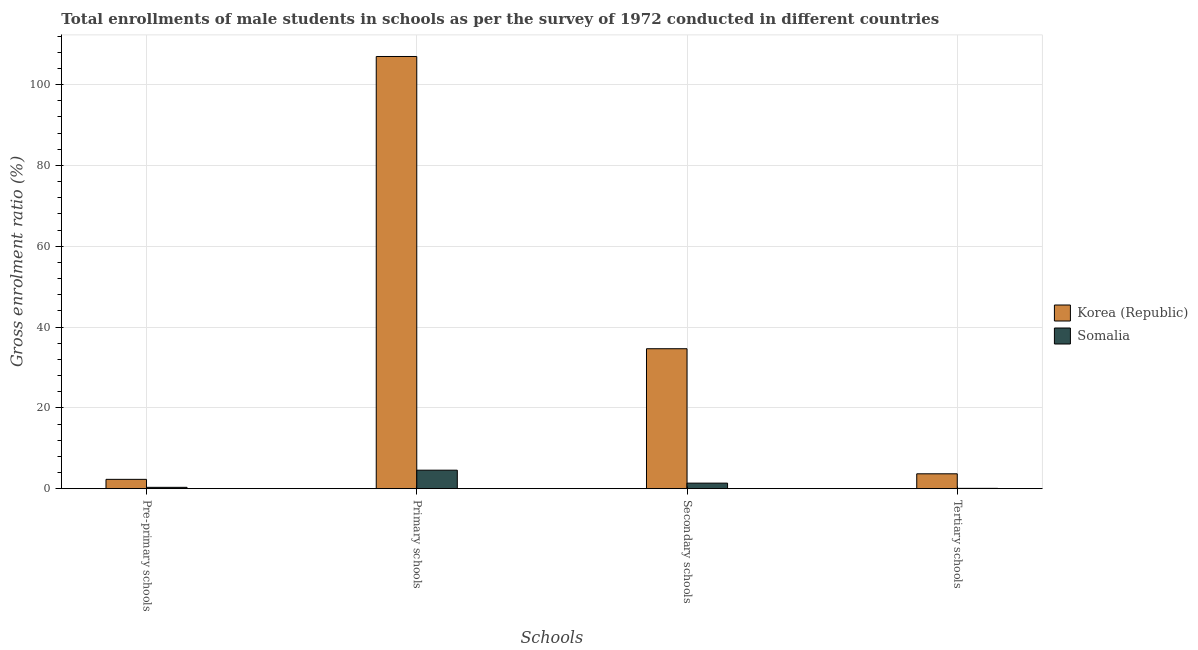How many groups of bars are there?
Your answer should be very brief. 4. Are the number of bars per tick equal to the number of legend labels?
Keep it short and to the point. Yes. Are the number of bars on each tick of the X-axis equal?
Keep it short and to the point. Yes. How many bars are there on the 3rd tick from the left?
Provide a succinct answer. 2. What is the label of the 3rd group of bars from the left?
Your answer should be very brief. Secondary schools. What is the gross enrolment ratio(male) in secondary schools in Korea (Republic)?
Your answer should be compact. 34.63. Across all countries, what is the maximum gross enrolment ratio(male) in tertiary schools?
Offer a very short reply. 3.68. Across all countries, what is the minimum gross enrolment ratio(male) in secondary schools?
Give a very brief answer. 1.37. In which country was the gross enrolment ratio(male) in pre-primary schools maximum?
Provide a short and direct response. Korea (Republic). In which country was the gross enrolment ratio(male) in primary schools minimum?
Your answer should be compact. Somalia. What is the total gross enrolment ratio(male) in secondary schools in the graph?
Offer a very short reply. 36. What is the difference between the gross enrolment ratio(male) in pre-primary schools in Korea (Republic) and that in Somalia?
Give a very brief answer. 1.97. What is the difference between the gross enrolment ratio(male) in tertiary schools in Korea (Republic) and the gross enrolment ratio(male) in pre-primary schools in Somalia?
Provide a succinct answer. 3.35. What is the average gross enrolment ratio(male) in tertiary schools per country?
Your response must be concise. 1.88. What is the difference between the gross enrolment ratio(male) in primary schools and gross enrolment ratio(male) in secondary schools in Somalia?
Make the answer very short. 3.2. What is the ratio of the gross enrolment ratio(male) in pre-primary schools in Korea (Republic) to that in Somalia?
Your response must be concise. 6.93. What is the difference between the highest and the second highest gross enrolment ratio(male) in primary schools?
Provide a short and direct response. 102.37. What is the difference between the highest and the lowest gross enrolment ratio(male) in primary schools?
Offer a terse response. 102.37. In how many countries, is the gross enrolment ratio(male) in secondary schools greater than the average gross enrolment ratio(male) in secondary schools taken over all countries?
Make the answer very short. 1. Is it the case that in every country, the sum of the gross enrolment ratio(male) in pre-primary schools and gross enrolment ratio(male) in tertiary schools is greater than the sum of gross enrolment ratio(male) in secondary schools and gross enrolment ratio(male) in primary schools?
Your answer should be compact. No. What does the 2nd bar from the left in Primary schools represents?
Your answer should be very brief. Somalia. How many bars are there?
Offer a very short reply. 8. How many countries are there in the graph?
Make the answer very short. 2. Are the values on the major ticks of Y-axis written in scientific E-notation?
Provide a short and direct response. No. How many legend labels are there?
Your answer should be very brief. 2. How are the legend labels stacked?
Ensure brevity in your answer.  Vertical. What is the title of the graph?
Provide a short and direct response. Total enrollments of male students in schools as per the survey of 1972 conducted in different countries. What is the label or title of the X-axis?
Provide a short and direct response. Schools. What is the Gross enrolment ratio (%) of Korea (Republic) in Pre-primary schools?
Provide a succinct answer. 2.31. What is the Gross enrolment ratio (%) in Somalia in Pre-primary schools?
Make the answer very short. 0.33. What is the Gross enrolment ratio (%) of Korea (Republic) in Primary schools?
Provide a succinct answer. 106.94. What is the Gross enrolment ratio (%) of Somalia in Primary schools?
Make the answer very short. 4.58. What is the Gross enrolment ratio (%) of Korea (Republic) in Secondary schools?
Offer a very short reply. 34.63. What is the Gross enrolment ratio (%) of Somalia in Secondary schools?
Give a very brief answer. 1.37. What is the Gross enrolment ratio (%) in Korea (Republic) in Tertiary schools?
Your answer should be compact. 3.68. What is the Gross enrolment ratio (%) of Somalia in Tertiary schools?
Your answer should be very brief. 0.08. Across all Schools, what is the maximum Gross enrolment ratio (%) of Korea (Republic)?
Your answer should be compact. 106.94. Across all Schools, what is the maximum Gross enrolment ratio (%) in Somalia?
Offer a very short reply. 4.58. Across all Schools, what is the minimum Gross enrolment ratio (%) in Korea (Republic)?
Make the answer very short. 2.31. Across all Schools, what is the minimum Gross enrolment ratio (%) in Somalia?
Make the answer very short. 0.08. What is the total Gross enrolment ratio (%) in Korea (Republic) in the graph?
Keep it short and to the point. 147.56. What is the total Gross enrolment ratio (%) of Somalia in the graph?
Give a very brief answer. 6.36. What is the difference between the Gross enrolment ratio (%) in Korea (Republic) in Pre-primary schools and that in Primary schools?
Make the answer very short. -104.64. What is the difference between the Gross enrolment ratio (%) of Somalia in Pre-primary schools and that in Primary schools?
Provide a short and direct response. -4.24. What is the difference between the Gross enrolment ratio (%) in Korea (Republic) in Pre-primary schools and that in Secondary schools?
Keep it short and to the point. -32.32. What is the difference between the Gross enrolment ratio (%) of Somalia in Pre-primary schools and that in Secondary schools?
Provide a short and direct response. -1.04. What is the difference between the Gross enrolment ratio (%) of Korea (Republic) in Pre-primary schools and that in Tertiary schools?
Keep it short and to the point. -1.37. What is the difference between the Gross enrolment ratio (%) in Somalia in Pre-primary schools and that in Tertiary schools?
Your answer should be compact. 0.25. What is the difference between the Gross enrolment ratio (%) of Korea (Republic) in Primary schools and that in Secondary schools?
Provide a short and direct response. 72.32. What is the difference between the Gross enrolment ratio (%) in Somalia in Primary schools and that in Secondary schools?
Ensure brevity in your answer.  3.2. What is the difference between the Gross enrolment ratio (%) of Korea (Republic) in Primary schools and that in Tertiary schools?
Make the answer very short. 103.26. What is the difference between the Gross enrolment ratio (%) in Somalia in Primary schools and that in Tertiary schools?
Your answer should be very brief. 4.5. What is the difference between the Gross enrolment ratio (%) of Korea (Republic) in Secondary schools and that in Tertiary schools?
Give a very brief answer. 30.95. What is the difference between the Gross enrolment ratio (%) in Somalia in Secondary schools and that in Tertiary schools?
Keep it short and to the point. 1.29. What is the difference between the Gross enrolment ratio (%) in Korea (Republic) in Pre-primary schools and the Gross enrolment ratio (%) in Somalia in Primary schools?
Your answer should be compact. -2.27. What is the difference between the Gross enrolment ratio (%) of Korea (Republic) in Pre-primary schools and the Gross enrolment ratio (%) of Somalia in Secondary schools?
Offer a terse response. 0.93. What is the difference between the Gross enrolment ratio (%) in Korea (Republic) in Pre-primary schools and the Gross enrolment ratio (%) in Somalia in Tertiary schools?
Offer a terse response. 2.23. What is the difference between the Gross enrolment ratio (%) of Korea (Republic) in Primary schools and the Gross enrolment ratio (%) of Somalia in Secondary schools?
Make the answer very short. 105.57. What is the difference between the Gross enrolment ratio (%) of Korea (Republic) in Primary schools and the Gross enrolment ratio (%) of Somalia in Tertiary schools?
Your response must be concise. 106.87. What is the difference between the Gross enrolment ratio (%) in Korea (Republic) in Secondary schools and the Gross enrolment ratio (%) in Somalia in Tertiary schools?
Offer a very short reply. 34.55. What is the average Gross enrolment ratio (%) of Korea (Republic) per Schools?
Make the answer very short. 36.89. What is the average Gross enrolment ratio (%) in Somalia per Schools?
Provide a short and direct response. 1.59. What is the difference between the Gross enrolment ratio (%) in Korea (Republic) and Gross enrolment ratio (%) in Somalia in Pre-primary schools?
Offer a terse response. 1.97. What is the difference between the Gross enrolment ratio (%) of Korea (Republic) and Gross enrolment ratio (%) of Somalia in Primary schools?
Ensure brevity in your answer.  102.37. What is the difference between the Gross enrolment ratio (%) in Korea (Republic) and Gross enrolment ratio (%) in Somalia in Secondary schools?
Your answer should be very brief. 33.26. What is the difference between the Gross enrolment ratio (%) in Korea (Republic) and Gross enrolment ratio (%) in Somalia in Tertiary schools?
Make the answer very short. 3.6. What is the ratio of the Gross enrolment ratio (%) of Korea (Republic) in Pre-primary schools to that in Primary schools?
Ensure brevity in your answer.  0.02. What is the ratio of the Gross enrolment ratio (%) of Somalia in Pre-primary schools to that in Primary schools?
Your answer should be compact. 0.07. What is the ratio of the Gross enrolment ratio (%) of Korea (Republic) in Pre-primary schools to that in Secondary schools?
Ensure brevity in your answer.  0.07. What is the ratio of the Gross enrolment ratio (%) of Somalia in Pre-primary schools to that in Secondary schools?
Keep it short and to the point. 0.24. What is the ratio of the Gross enrolment ratio (%) in Korea (Republic) in Pre-primary schools to that in Tertiary schools?
Provide a succinct answer. 0.63. What is the ratio of the Gross enrolment ratio (%) in Somalia in Pre-primary schools to that in Tertiary schools?
Keep it short and to the point. 4.23. What is the ratio of the Gross enrolment ratio (%) in Korea (Republic) in Primary schools to that in Secondary schools?
Your response must be concise. 3.09. What is the ratio of the Gross enrolment ratio (%) of Somalia in Primary schools to that in Secondary schools?
Provide a succinct answer. 3.34. What is the ratio of the Gross enrolment ratio (%) of Korea (Republic) in Primary schools to that in Tertiary schools?
Your answer should be very brief. 29.05. What is the ratio of the Gross enrolment ratio (%) of Somalia in Primary schools to that in Tertiary schools?
Your answer should be compact. 58.09. What is the ratio of the Gross enrolment ratio (%) in Korea (Republic) in Secondary schools to that in Tertiary schools?
Your response must be concise. 9.41. What is the ratio of the Gross enrolment ratio (%) of Somalia in Secondary schools to that in Tertiary schools?
Keep it short and to the point. 17.41. What is the difference between the highest and the second highest Gross enrolment ratio (%) in Korea (Republic)?
Ensure brevity in your answer.  72.32. What is the difference between the highest and the second highest Gross enrolment ratio (%) in Somalia?
Make the answer very short. 3.2. What is the difference between the highest and the lowest Gross enrolment ratio (%) of Korea (Republic)?
Give a very brief answer. 104.64. What is the difference between the highest and the lowest Gross enrolment ratio (%) of Somalia?
Offer a terse response. 4.5. 